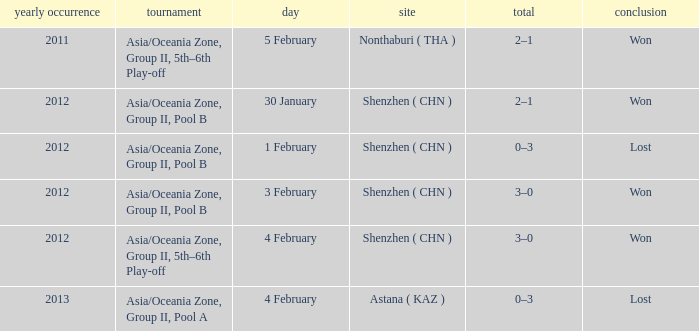What was the location for a year later than 2012? Astana ( KAZ ). 